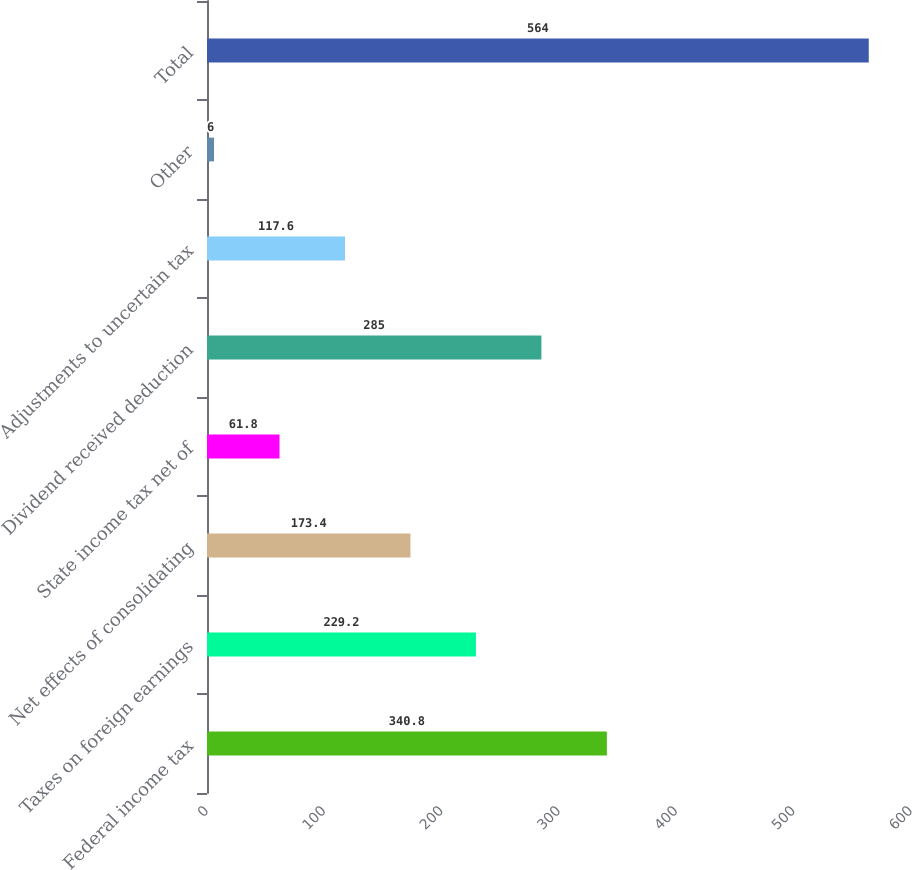Convert chart. <chart><loc_0><loc_0><loc_500><loc_500><bar_chart><fcel>Federal income tax<fcel>Taxes on foreign earnings<fcel>Net effects of consolidating<fcel>State income tax net of<fcel>Dividend received deduction<fcel>Adjustments to uncertain tax<fcel>Other<fcel>Total<nl><fcel>340.8<fcel>229.2<fcel>173.4<fcel>61.8<fcel>285<fcel>117.6<fcel>6<fcel>564<nl></chart> 